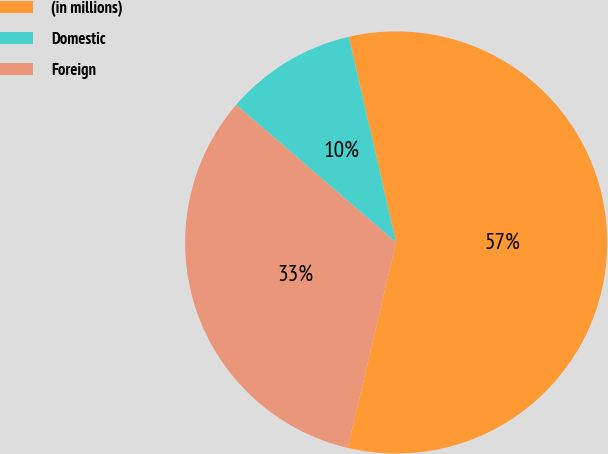Convert chart. <chart><loc_0><loc_0><loc_500><loc_500><pie_chart><fcel>(in millions)<fcel>Domestic<fcel>Foreign<nl><fcel>57.29%<fcel>10.09%<fcel>32.62%<nl></chart> 